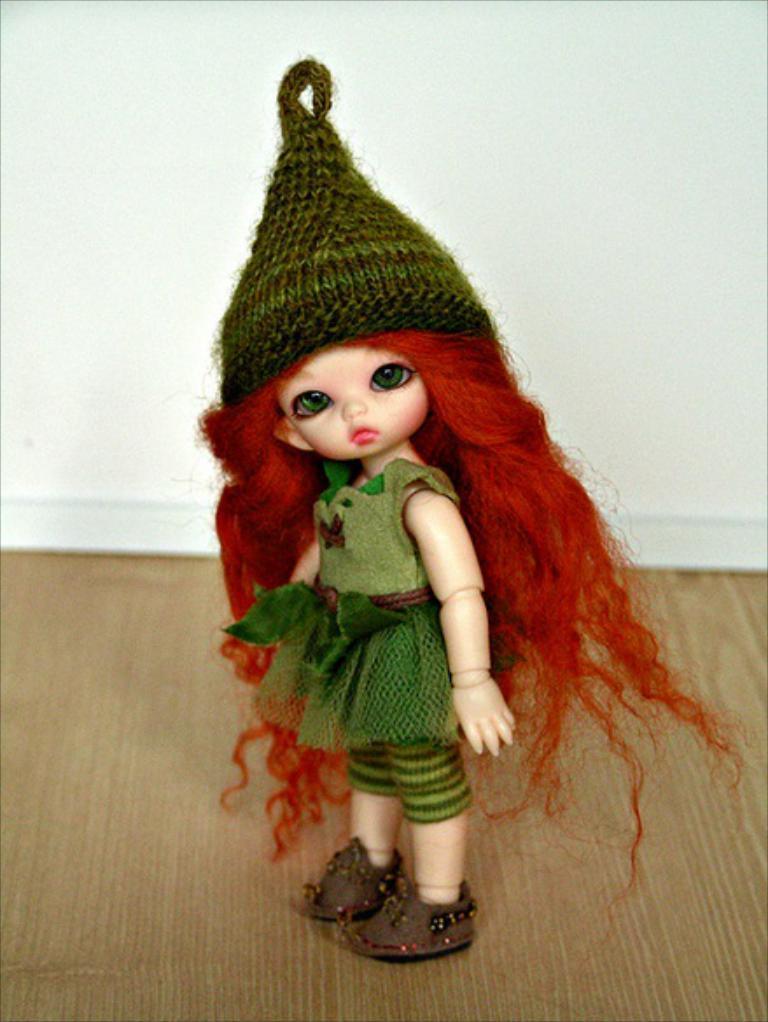Could you give a brief overview of what you see in this image? In this image I can see a barbie toy along with a green color dress. In the background, I can see a white color wall. 